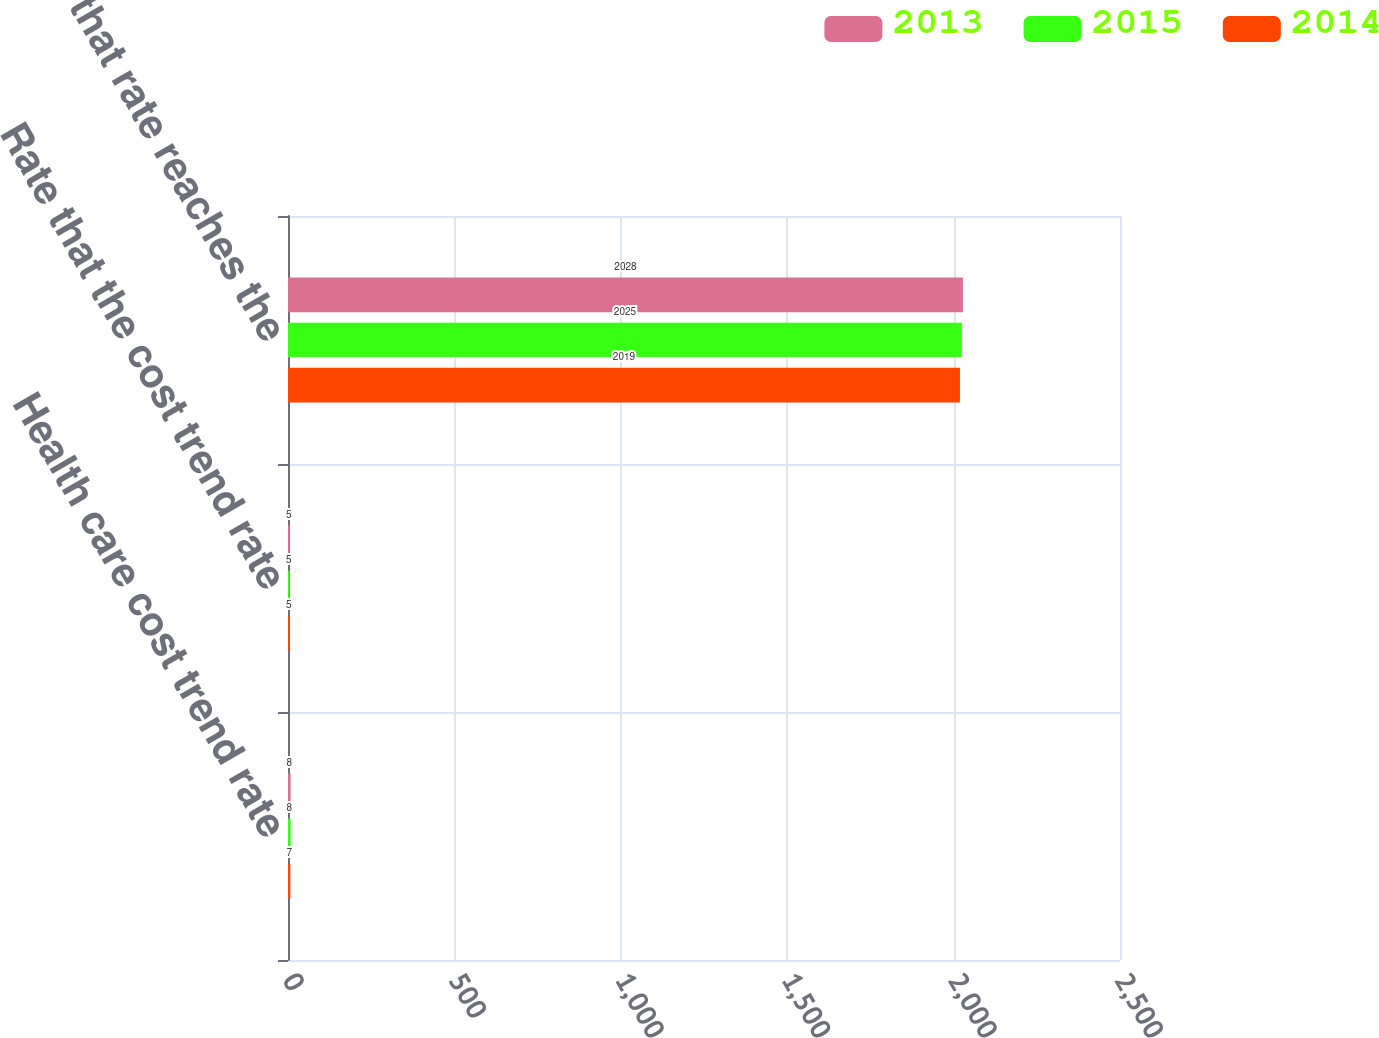Convert chart to OTSL. <chart><loc_0><loc_0><loc_500><loc_500><stacked_bar_chart><ecel><fcel>Health care cost trend rate<fcel>Rate that the cost trend rate<fcel>Year that rate reaches the<nl><fcel>2013<fcel>8<fcel>5<fcel>2028<nl><fcel>2015<fcel>8<fcel>5<fcel>2025<nl><fcel>2014<fcel>7<fcel>5<fcel>2019<nl></chart> 